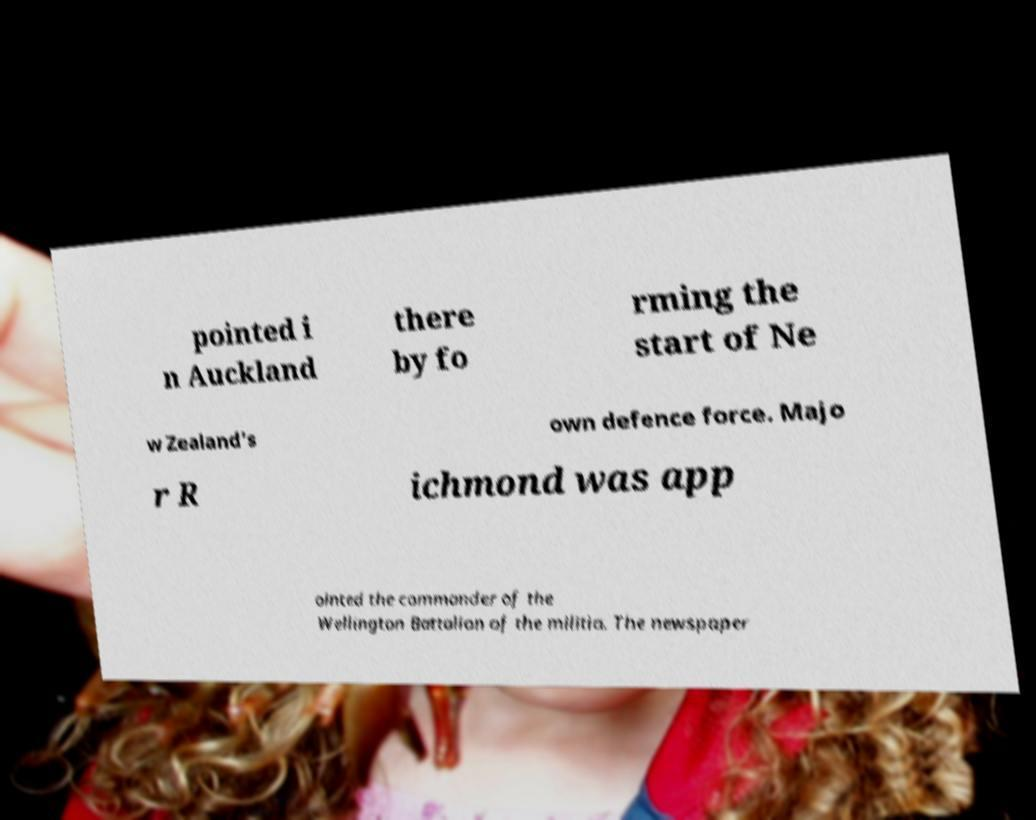For documentation purposes, I need the text within this image transcribed. Could you provide that? pointed i n Auckland there by fo rming the start of Ne w Zealand's own defence force. Majo r R ichmond was app ointed the commander of the Wellington Battalion of the militia. The newspaper 